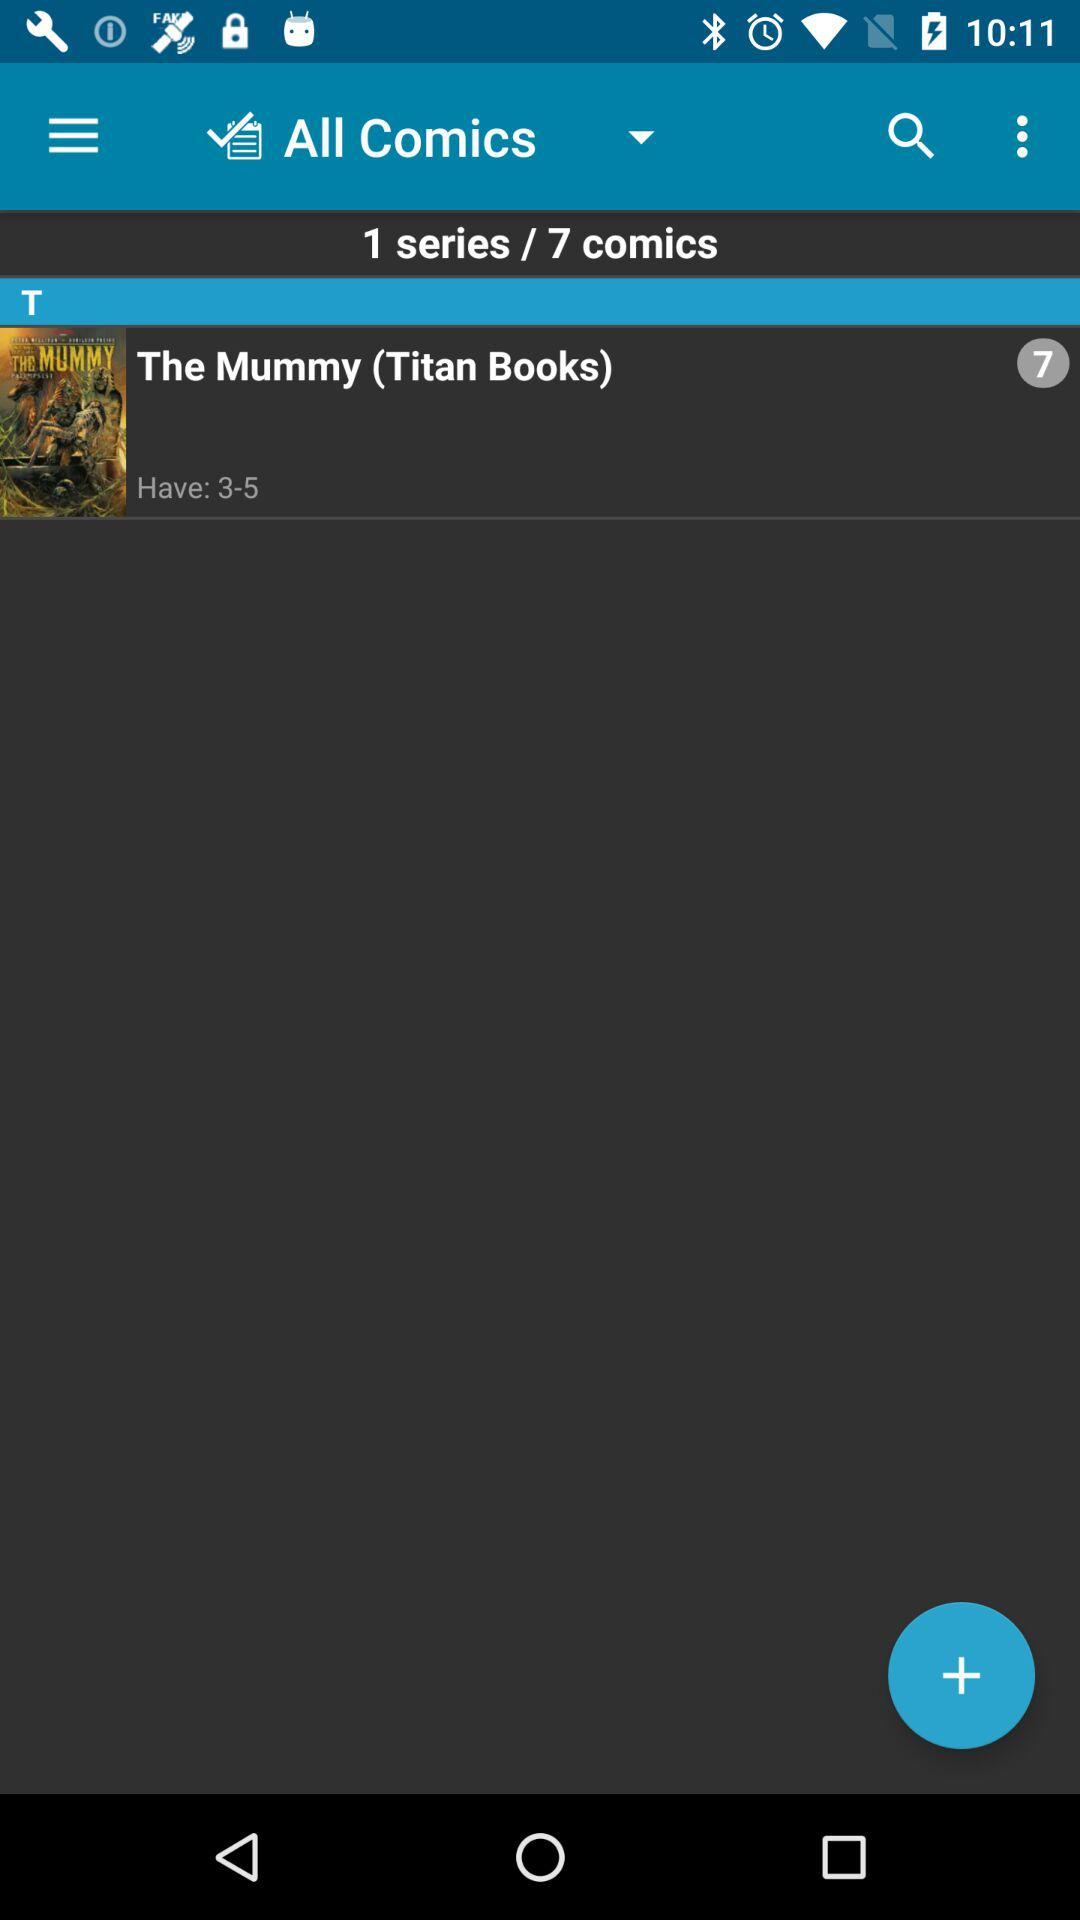How many series are there? There is 1 series. 